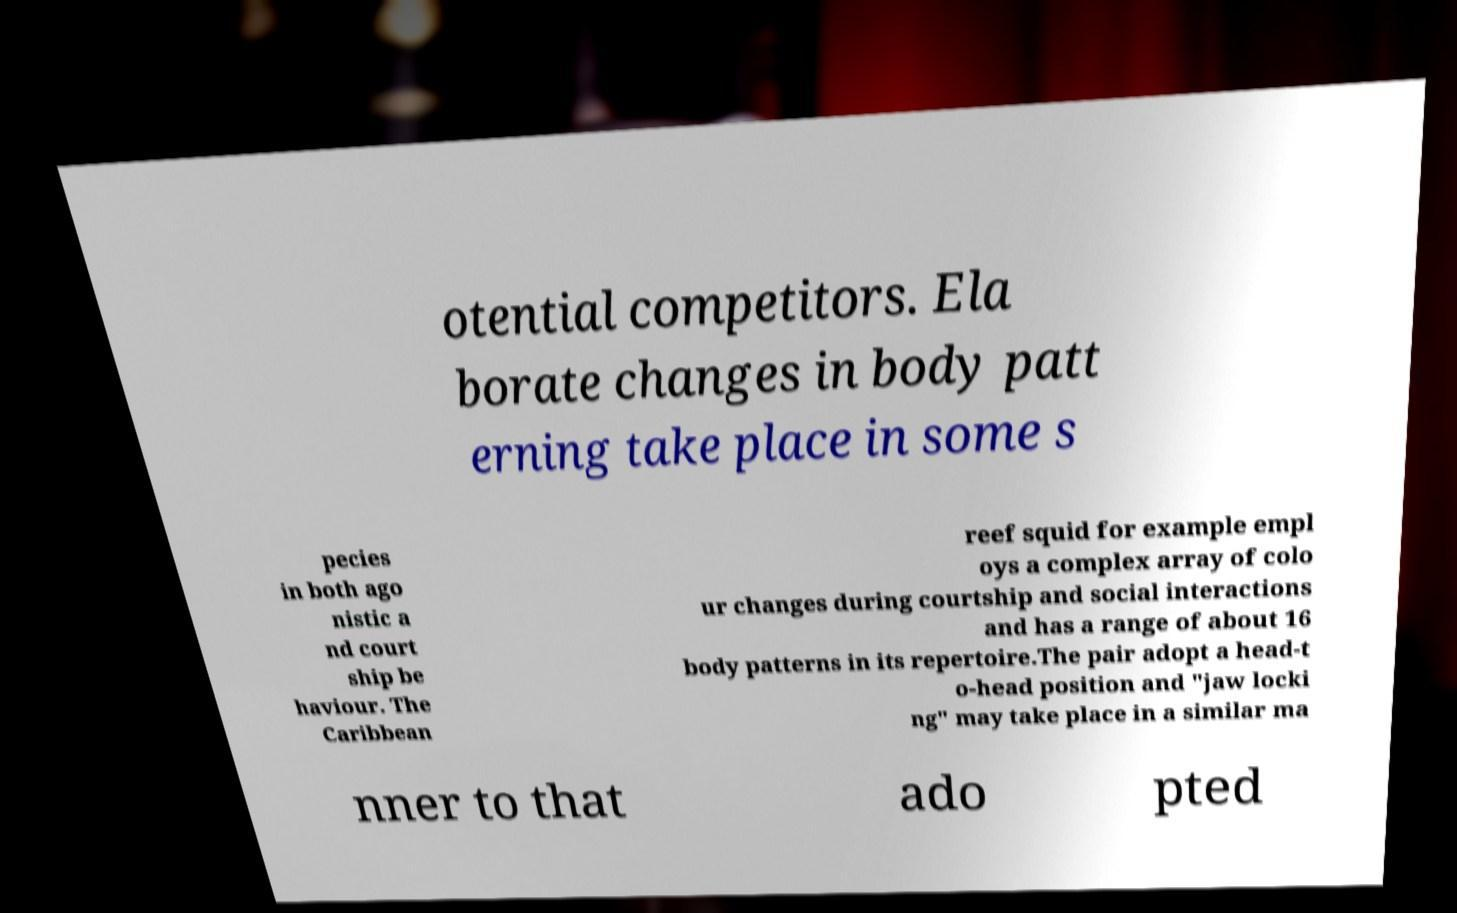For documentation purposes, I need the text within this image transcribed. Could you provide that? otential competitors. Ela borate changes in body patt erning take place in some s pecies in both ago nistic a nd court ship be haviour. The Caribbean reef squid for example empl oys a complex array of colo ur changes during courtship and social interactions and has a range of about 16 body patterns in its repertoire.The pair adopt a head-t o-head position and "jaw locki ng" may take place in a similar ma nner to that ado pted 